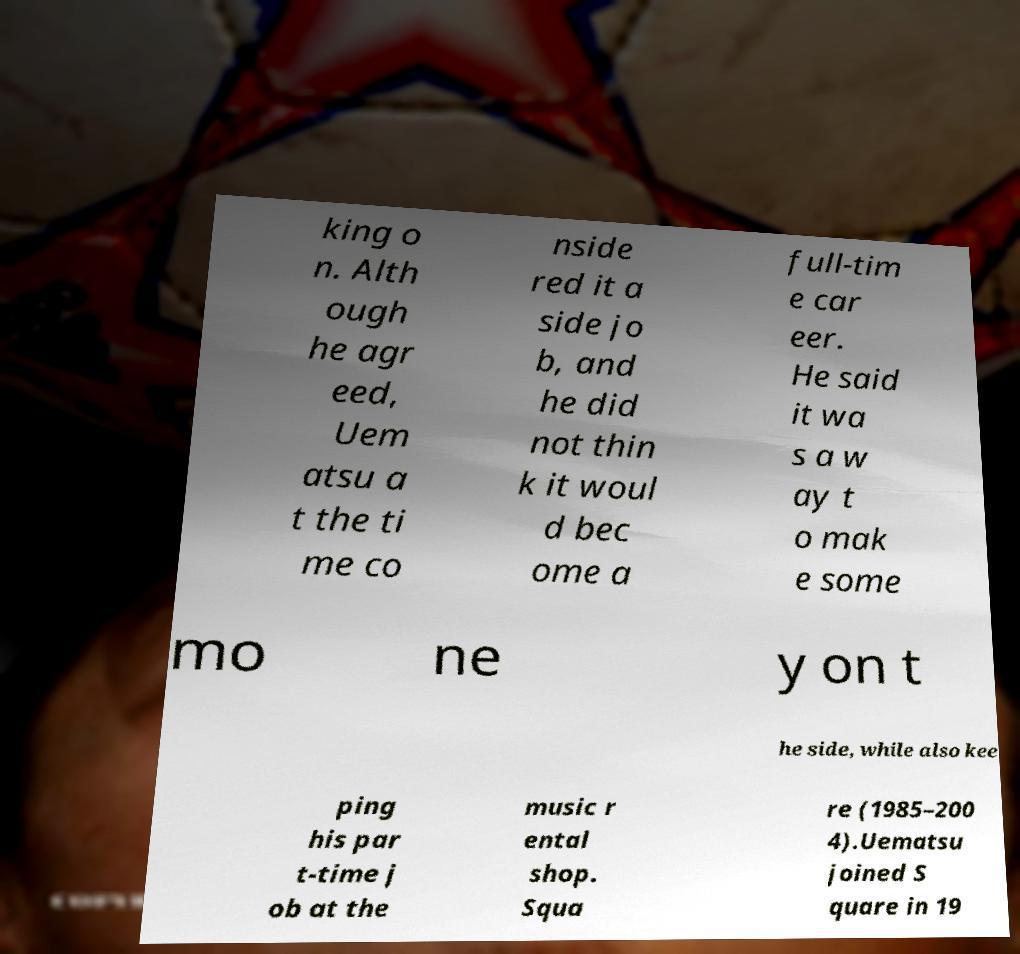Can you read and provide the text displayed in the image?This photo seems to have some interesting text. Can you extract and type it out for me? king o n. Alth ough he agr eed, Uem atsu a t the ti me co nside red it a side jo b, and he did not thin k it woul d bec ome a full-tim e car eer. He said it wa s a w ay t o mak e some mo ne y on t he side, while also kee ping his par t-time j ob at the music r ental shop. Squa re (1985–200 4).Uematsu joined S quare in 19 